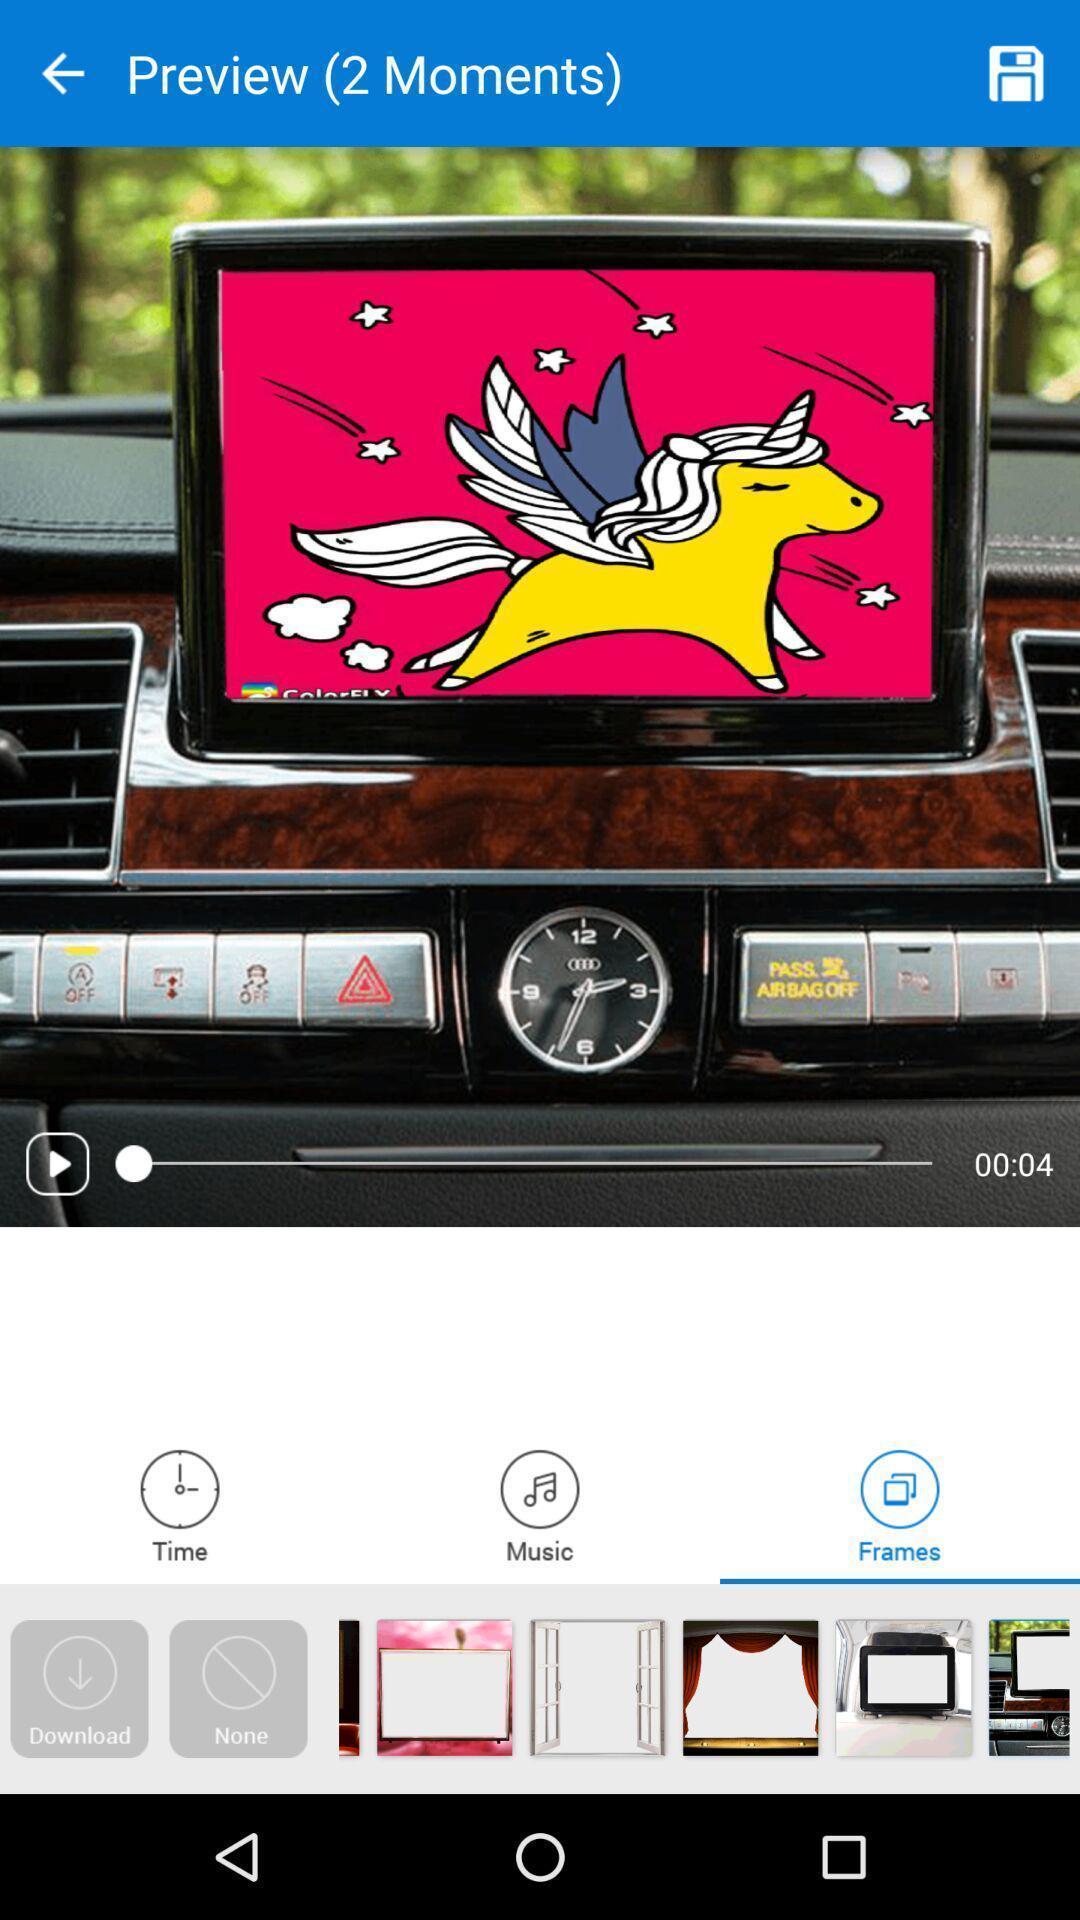Tell me about the visual elements in this screen capture. Screen showing different frames. 